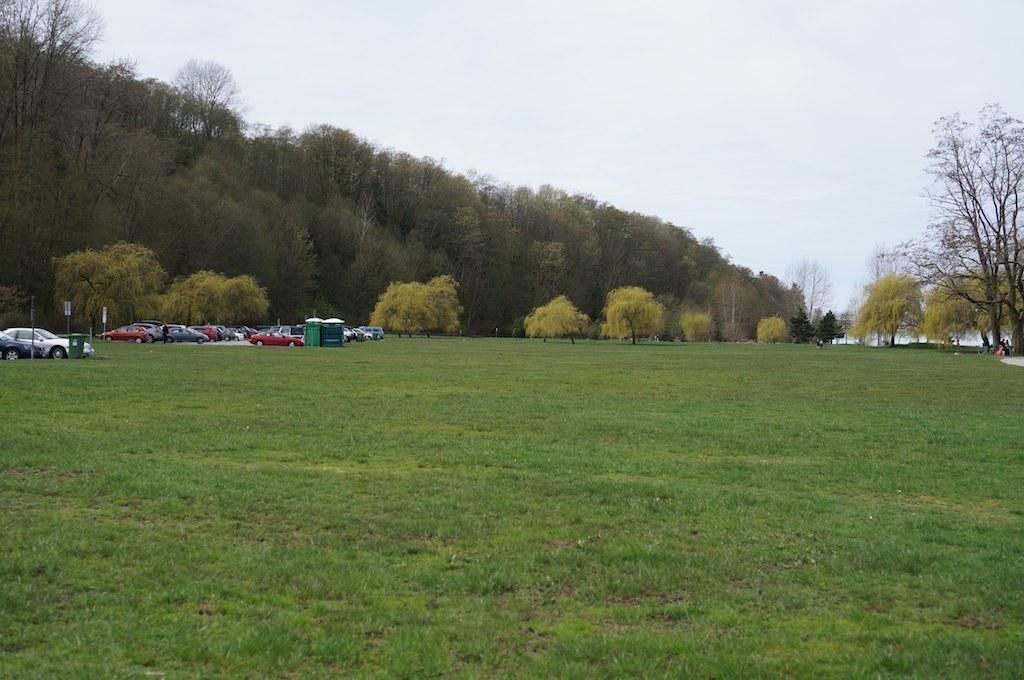Can you describe this image briefly? In this picture we can see few vehicles on the grass, and also we can find few sign boards, trees and water. 